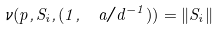<formula> <loc_0><loc_0><loc_500><loc_500>\nu ( p , S _ { i } , ( 1 , \ a / d ^ { - 1 } ) ) = \| S _ { i } \|</formula> 